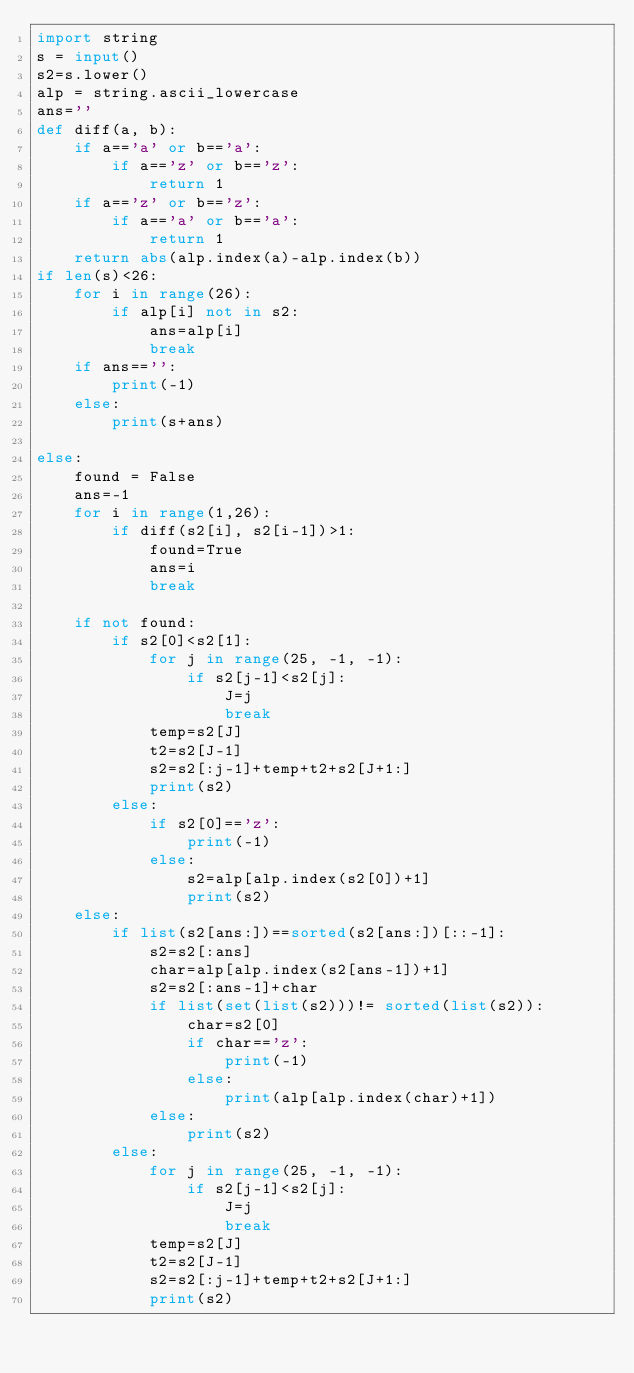<code> <loc_0><loc_0><loc_500><loc_500><_Python_>import string
s = input()
s2=s.lower()
alp = string.ascii_lowercase
ans=''
def diff(a, b):
    if a=='a' or b=='a':
        if a=='z' or b=='z':
            return 1
    if a=='z' or b=='z':
        if a=='a' or b=='a':
            return 1
    return abs(alp.index(a)-alp.index(b))
if len(s)<26:
    for i in range(26):
        if alp[i] not in s2:
            ans=alp[i]
            break
    if ans=='':
        print(-1)
    else:
        print(s+ans)
        
else:
    found = False
    ans=-1
    for i in range(1,26):
        if diff(s2[i], s2[i-1])>1:
            found=True
            ans=i
            break

    if not found:
        if s2[0]<s2[1]:
            for j in range(25, -1, -1):
                if s2[j-1]<s2[j]:
                    J=j
                    break
            temp=s2[J]
            t2=s2[J-1]
            s2=s2[:j-1]+temp+t2+s2[J+1:]
            print(s2)
        else:
            if s2[0]=='z':
                print(-1)
            else:
                s2=alp[alp.index(s2[0])+1]
                print(s2)
    else:
        if list(s2[ans:])==sorted(s2[ans:])[::-1]:
            s2=s2[:ans]
            char=alp[alp.index(s2[ans-1])+1]
            s2=s2[:ans-1]+char
            if list(set(list(s2)))!= sorted(list(s2)):
                char=s2[0]
                if char=='z':
                    print(-1)
                else:
                    print(alp[alp.index(char)+1])
            else:
                print(s2)
        else:
            for j in range(25, -1, -1):
                if s2[j-1]<s2[j]:
                    J=j
                    break
            temp=s2[J]
            t2=s2[J-1]
            s2=s2[:j-1]+temp+t2+s2[J+1:]
            print(s2)
</code> 